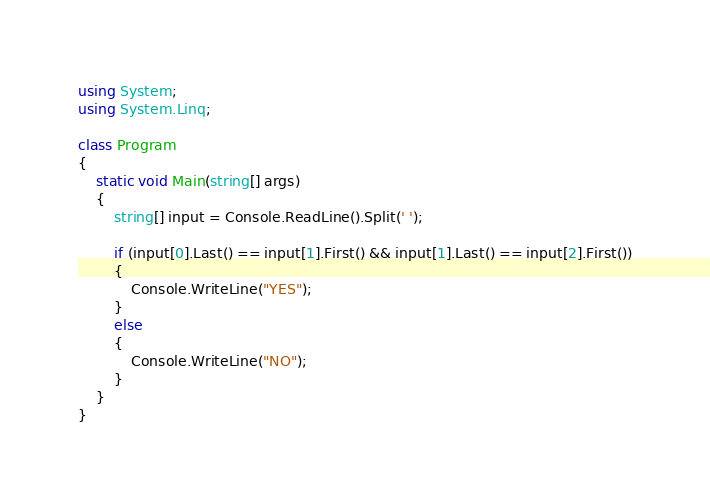Convert code to text. <code><loc_0><loc_0><loc_500><loc_500><_C#_>using System;
using System.Linq;

class Program
{
	static void Main(string[] args)
	{
        string[] input = Console.ReadLine().Split(' ');

        if (input[0].Last() == input[1].First() && input[1].Last() == input[2].First())
        {
            Console.WriteLine("YES");
        }
        else
        {
            Console.WriteLine("NO");
        }
	}
}</code> 